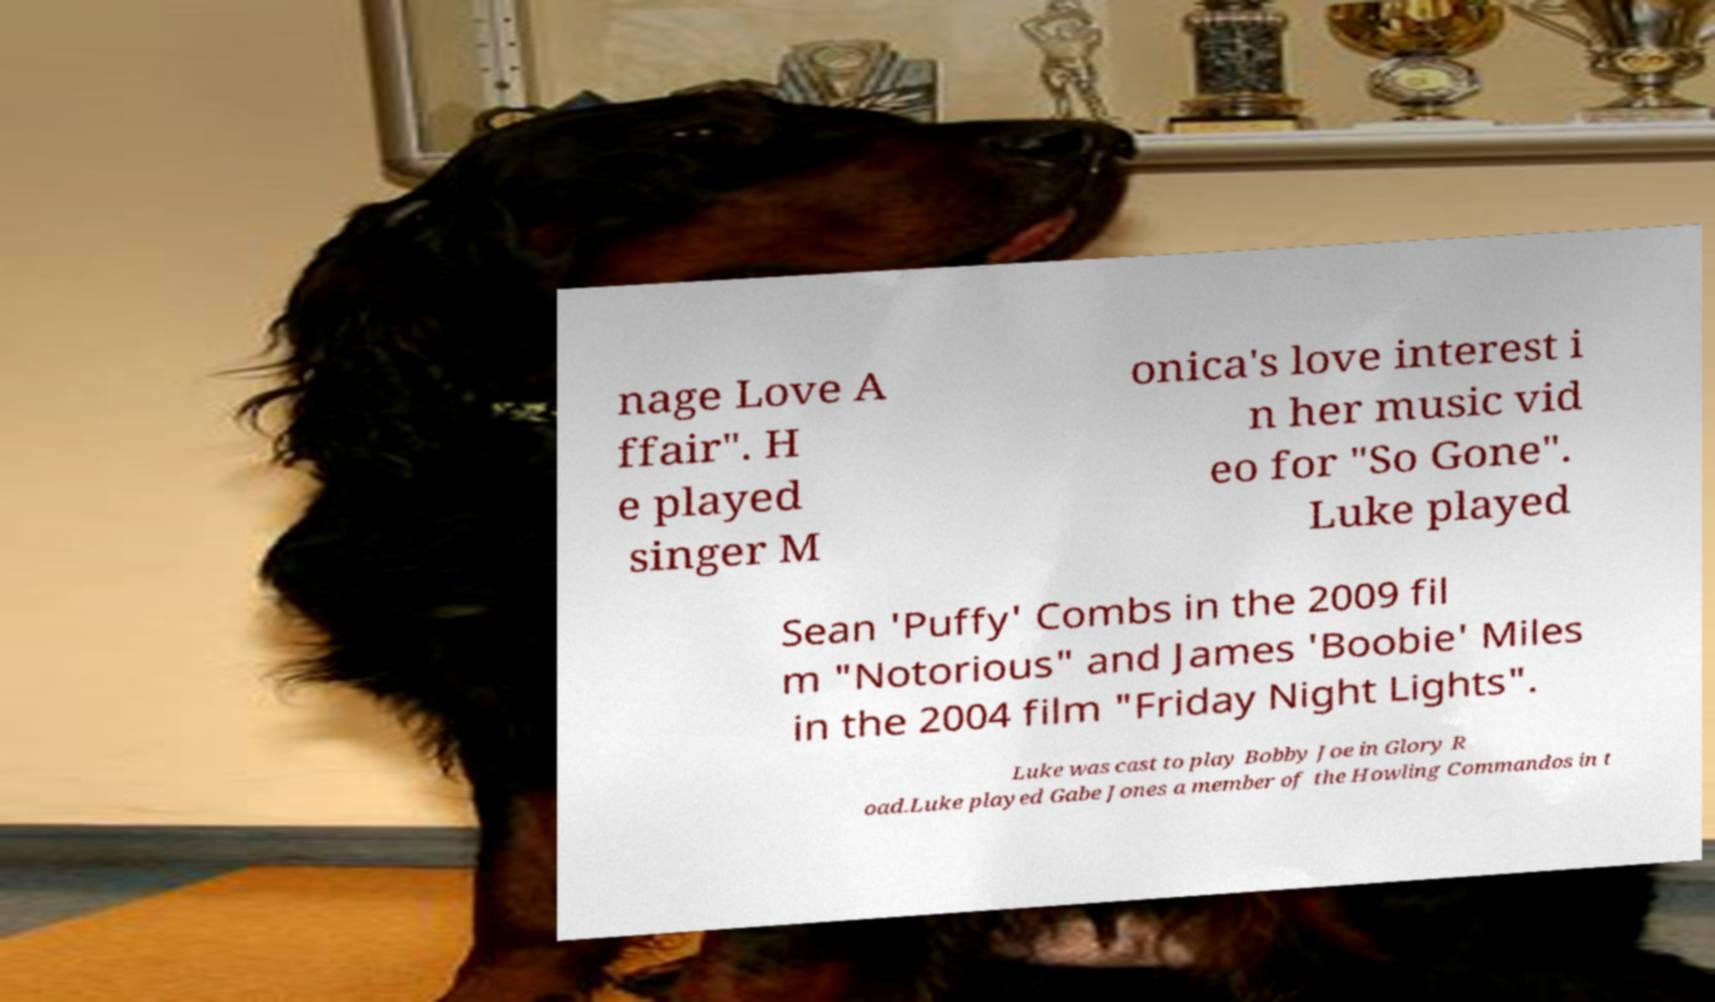There's text embedded in this image that I need extracted. Can you transcribe it verbatim? nage Love A ffair". H e played singer M onica's love interest i n her music vid eo for "So Gone". Luke played Sean 'Puffy' Combs in the 2009 fil m "Notorious" and James 'Boobie' Miles in the 2004 film "Friday Night Lights". Luke was cast to play Bobby Joe in Glory R oad.Luke played Gabe Jones a member of the Howling Commandos in t 